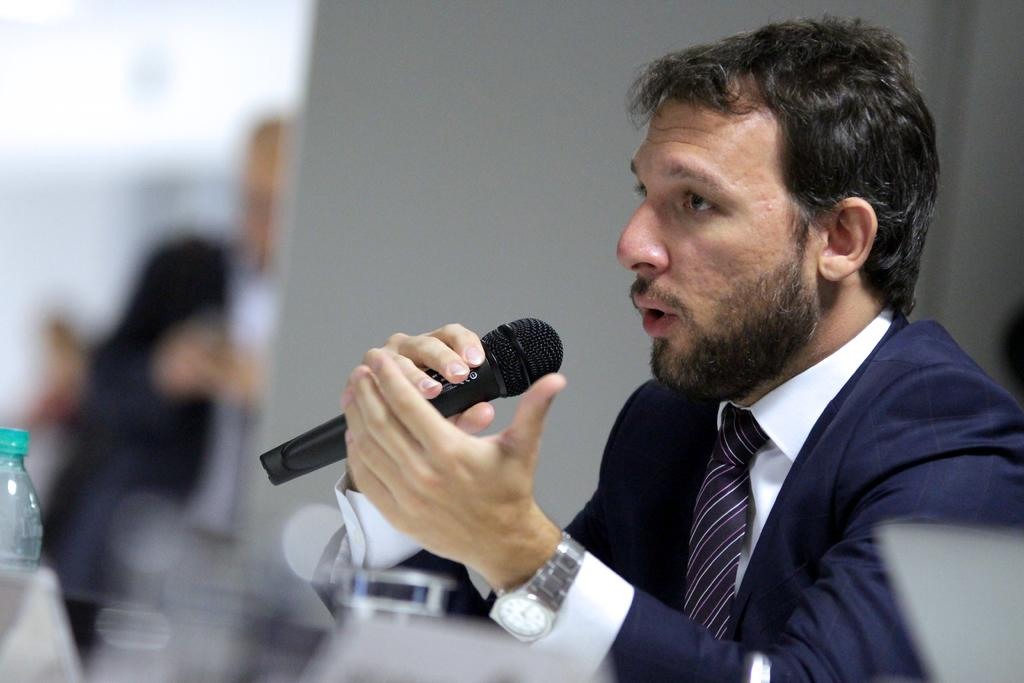What is the man in the image doing? The man is talking in a mic. What is the man wearing in the image? The man is wearing a blue suit. What can be seen on the table in the image? There is a bottle on a table in the image. How would you describe the background of the image? The background of the image is blurred. How many ladybugs are crawling on the cheese in the image? There is no cheese or ladybugs present in the image. What type of road can be seen in the background of the image? There is no road visible in the image; the background is blurred. 